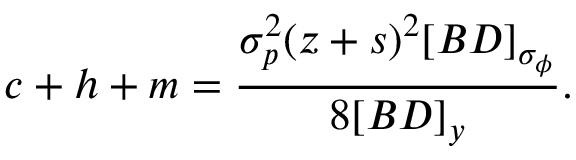<formula> <loc_0><loc_0><loc_500><loc_500>c + h + m = \frac { \sigma _ { p } ^ { 2 } ( z + s ) ^ { 2 } [ B D ] _ { \sigma _ { \phi } } } { 8 [ B D ] _ { y } } .</formula> 